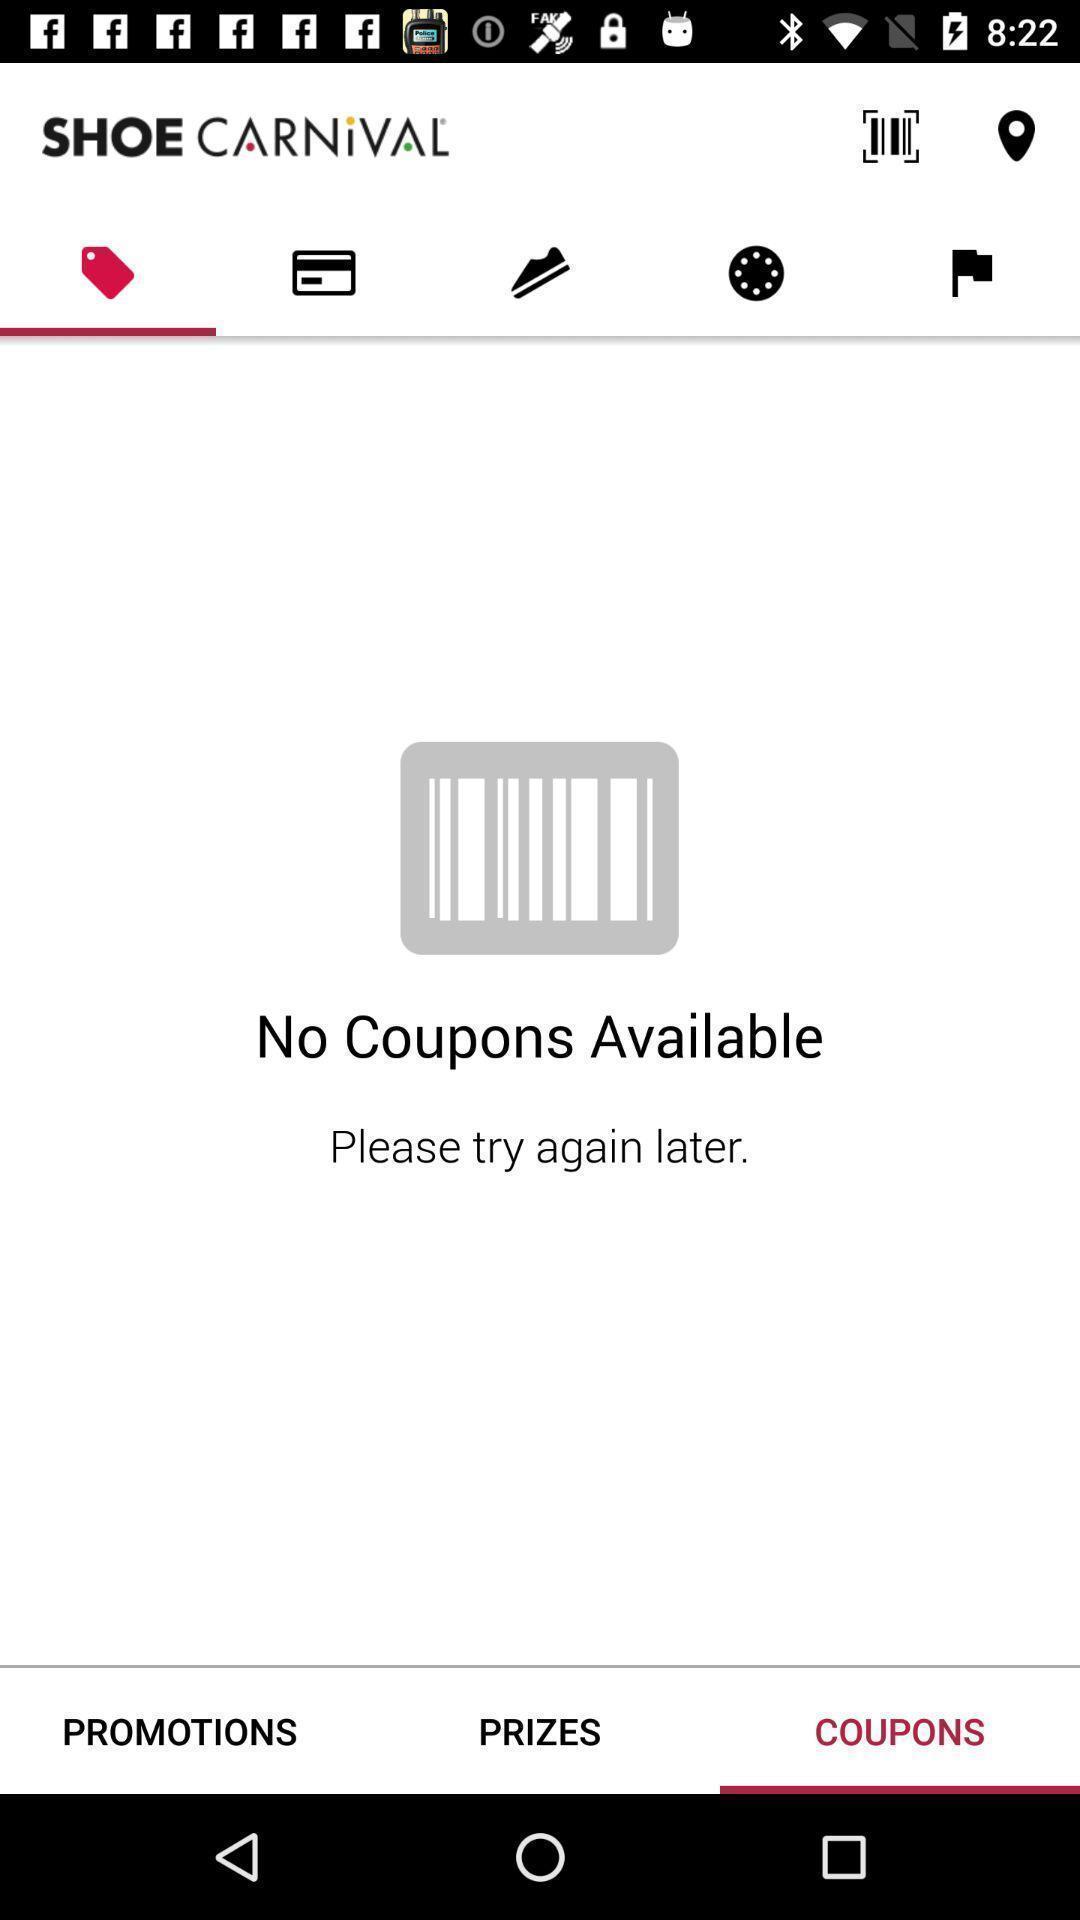Give me a narrative description of this picture. Screen displaying multiple options in a shopping application. 